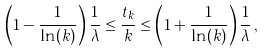<formula> <loc_0><loc_0><loc_500><loc_500>\left ( 1 - \frac { 1 } { \ln ( k ) } \right ) \frac { 1 } { \lambda } \leq \frac { t _ { k } } { k } \leq \left ( 1 + \frac { 1 } { \ln ( k ) } \right ) \frac { 1 } { \lambda } \, ,</formula> 